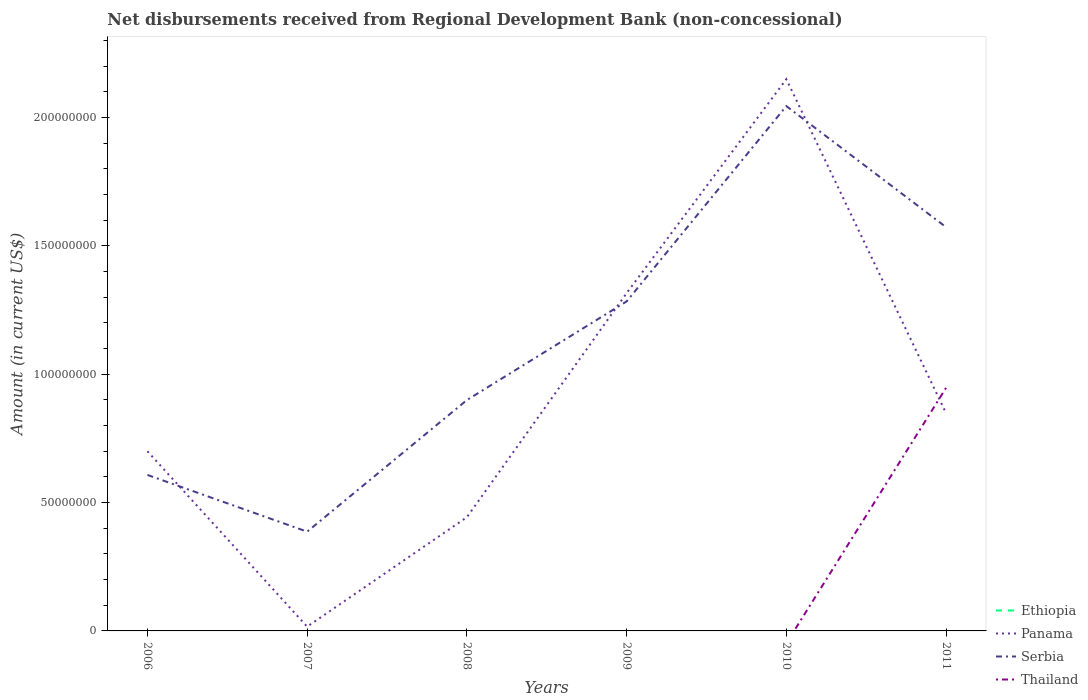How many different coloured lines are there?
Offer a very short reply. 3. Does the line corresponding to Ethiopia intersect with the line corresponding to Thailand?
Provide a succinct answer. Yes. Is the number of lines equal to the number of legend labels?
Give a very brief answer. No. What is the total amount of disbursements received from Regional Development Bank in Serbia in the graph?
Provide a short and direct response. -1.66e+08. What is the difference between the highest and the second highest amount of disbursements received from Regional Development Bank in Thailand?
Offer a terse response. 9.47e+07. What is the difference between the highest and the lowest amount of disbursements received from Regional Development Bank in Panama?
Provide a succinct answer. 2. Is the amount of disbursements received from Regional Development Bank in Panama strictly greater than the amount of disbursements received from Regional Development Bank in Thailand over the years?
Make the answer very short. No. Are the values on the major ticks of Y-axis written in scientific E-notation?
Your answer should be very brief. No. Does the graph contain any zero values?
Keep it short and to the point. Yes. How many legend labels are there?
Your answer should be compact. 4. What is the title of the graph?
Give a very brief answer. Net disbursements received from Regional Development Bank (non-concessional). Does "Europe(all income levels)" appear as one of the legend labels in the graph?
Keep it short and to the point. No. What is the Amount (in current US$) in Panama in 2006?
Ensure brevity in your answer.  7.00e+07. What is the Amount (in current US$) of Serbia in 2006?
Provide a short and direct response. 6.08e+07. What is the Amount (in current US$) in Panama in 2007?
Your response must be concise. 1.66e+06. What is the Amount (in current US$) of Serbia in 2007?
Your answer should be very brief. 3.87e+07. What is the Amount (in current US$) in Panama in 2008?
Offer a terse response. 4.43e+07. What is the Amount (in current US$) in Serbia in 2008?
Give a very brief answer. 8.99e+07. What is the Amount (in current US$) of Thailand in 2008?
Offer a very short reply. 0. What is the Amount (in current US$) in Ethiopia in 2009?
Make the answer very short. 0. What is the Amount (in current US$) in Panama in 2009?
Provide a short and direct response. 1.32e+08. What is the Amount (in current US$) of Serbia in 2009?
Your answer should be compact. 1.28e+08. What is the Amount (in current US$) in Thailand in 2009?
Provide a succinct answer. 0. What is the Amount (in current US$) of Panama in 2010?
Offer a very short reply. 2.15e+08. What is the Amount (in current US$) in Serbia in 2010?
Give a very brief answer. 2.04e+08. What is the Amount (in current US$) of Ethiopia in 2011?
Offer a very short reply. 0. What is the Amount (in current US$) of Panama in 2011?
Keep it short and to the point. 8.48e+07. What is the Amount (in current US$) in Serbia in 2011?
Your answer should be very brief. 1.57e+08. What is the Amount (in current US$) in Thailand in 2011?
Give a very brief answer. 9.47e+07. Across all years, what is the maximum Amount (in current US$) in Panama?
Your answer should be compact. 2.15e+08. Across all years, what is the maximum Amount (in current US$) in Serbia?
Your answer should be very brief. 2.04e+08. Across all years, what is the maximum Amount (in current US$) of Thailand?
Provide a short and direct response. 9.47e+07. Across all years, what is the minimum Amount (in current US$) in Panama?
Make the answer very short. 1.66e+06. Across all years, what is the minimum Amount (in current US$) in Serbia?
Your answer should be very brief. 3.87e+07. Across all years, what is the minimum Amount (in current US$) of Thailand?
Ensure brevity in your answer.  0. What is the total Amount (in current US$) of Panama in the graph?
Provide a short and direct response. 5.47e+08. What is the total Amount (in current US$) of Serbia in the graph?
Make the answer very short. 6.79e+08. What is the total Amount (in current US$) of Thailand in the graph?
Your answer should be very brief. 9.47e+07. What is the difference between the Amount (in current US$) of Panama in 2006 and that in 2007?
Your answer should be very brief. 6.83e+07. What is the difference between the Amount (in current US$) in Serbia in 2006 and that in 2007?
Provide a succinct answer. 2.21e+07. What is the difference between the Amount (in current US$) of Panama in 2006 and that in 2008?
Offer a very short reply. 2.57e+07. What is the difference between the Amount (in current US$) in Serbia in 2006 and that in 2008?
Offer a terse response. -2.92e+07. What is the difference between the Amount (in current US$) in Panama in 2006 and that in 2009?
Provide a short and direct response. -6.16e+07. What is the difference between the Amount (in current US$) of Serbia in 2006 and that in 2009?
Provide a succinct answer. -6.76e+07. What is the difference between the Amount (in current US$) of Panama in 2006 and that in 2010?
Offer a very short reply. -1.45e+08. What is the difference between the Amount (in current US$) of Serbia in 2006 and that in 2010?
Your response must be concise. -1.44e+08. What is the difference between the Amount (in current US$) in Panama in 2006 and that in 2011?
Offer a very short reply. -1.48e+07. What is the difference between the Amount (in current US$) of Serbia in 2006 and that in 2011?
Make the answer very short. -9.65e+07. What is the difference between the Amount (in current US$) in Panama in 2007 and that in 2008?
Your response must be concise. -4.26e+07. What is the difference between the Amount (in current US$) of Serbia in 2007 and that in 2008?
Your response must be concise. -5.13e+07. What is the difference between the Amount (in current US$) in Panama in 2007 and that in 2009?
Your answer should be compact. -1.30e+08. What is the difference between the Amount (in current US$) in Serbia in 2007 and that in 2009?
Ensure brevity in your answer.  -8.97e+07. What is the difference between the Amount (in current US$) in Panama in 2007 and that in 2010?
Provide a short and direct response. -2.13e+08. What is the difference between the Amount (in current US$) in Serbia in 2007 and that in 2010?
Offer a terse response. -1.66e+08. What is the difference between the Amount (in current US$) of Panama in 2007 and that in 2011?
Your answer should be very brief. -8.32e+07. What is the difference between the Amount (in current US$) in Serbia in 2007 and that in 2011?
Your response must be concise. -1.19e+08. What is the difference between the Amount (in current US$) in Panama in 2008 and that in 2009?
Offer a terse response. -8.73e+07. What is the difference between the Amount (in current US$) in Serbia in 2008 and that in 2009?
Offer a very short reply. -3.84e+07. What is the difference between the Amount (in current US$) in Panama in 2008 and that in 2010?
Offer a terse response. -1.71e+08. What is the difference between the Amount (in current US$) in Serbia in 2008 and that in 2010?
Your answer should be compact. -1.15e+08. What is the difference between the Amount (in current US$) of Panama in 2008 and that in 2011?
Ensure brevity in your answer.  -4.05e+07. What is the difference between the Amount (in current US$) in Serbia in 2008 and that in 2011?
Give a very brief answer. -6.74e+07. What is the difference between the Amount (in current US$) in Panama in 2009 and that in 2010?
Offer a terse response. -8.33e+07. What is the difference between the Amount (in current US$) in Serbia in 2009 and that in 2010?
Your answer should be compact. -7.61e+07. What is the difference between the Amount (in current US$) in Panama in 2009 and that in 2011?
Provide a succinct answer. 4.67e+07. What is the difference between the Amount (in current US$) in Serbia in 2009 and that in 2011?
Offer a terse response. -2.89e+07. What is the difference between the Amount (in current US$) in Panama in 2010 and that in 2011?
Offer a very short reply. 1.30e+08. What is the difference between the Amount (in current US$) in Serbia in 2010 and that in 2011?
Offer a terse response. 4.72e+07. What is the difference between the Amount (in current US$) of Panama in 2006 and the Amount (in current US$) of Serbia in 2007?
Ensure brevity in your answer.  3.13e+07. What is the difference between the Amount (in current US$) of Panama in 2006 and the Amount (in current US$) of Serbia in 2008?
Provide a succinct answer. -1.99e+07. What is the difference between the Amount (in current US$) of Panama in 2006 and the Amount (in current US$) of Serbia in 2009?
Ensure brevity in your answer.  -5.84e+07. What is the difference between the Amount (in current US$) of Panama in 2006 and the Amount (in current US$) of Serbia in 2010?
Provide a short and direct response. -1.34e+08. What is the difference between the Amount (in current US$) of Panama in 2006 and the Amount (in current US$) of Serbia in 2011?
Give a very brief answer. -8.73e+07. What is the difference between the Amount (in current US$) of Panama in 2006 and the Amount (in current US$) of Thailand in 2011?
Your response must be concise. -2.47e+07. What is the difference between the Amount (in current US$) of Serbia in 2006 and the Amount (in current US$) of Thailand in 2011?
Your answer should be compact. -3.39e+07. What is the difference between the Amount (in current US$) in Panama in 2007 and the Amount (in current US$) in Serbia in 2008?
Ensure brevity in your answer.  -8.83e+07. What is the difference between the Amount (in current US$) of Panama in 2007 and the Amount (in current US$) of Serbia in 2009?
Keep it short and to the point. -1.27e+08. What is the difference between the Amount (in current US$) of Panama in 2007 and the Amount (in current US$) of Serbia in 2010?
Keep it short and to the point. -2.03e+08. What is the difference between the Amount (in current US$) of Panama in 2007 and the Amount (in current US$) of Serbia in 2011?
Your answer should be very brief. -1.56e+08. What is the difference between the Amount (in current US$) in Panama in 2007 and the Amount (in current US$) in Thailand in 2011?
Provide a succinct answer. -9.30e+07. What is the difference between the Amount (in current US$) in Serbia in 2007 and the Amount (in current US$) in Thailand in 2011?
Ensure brevity in your answer.  -5.60e+07. What is the difference between the Amount (in current US$) in Panama in 2008 and the Amount (in current US$) in Serbia in 2009?
Ensure brevity in your answer.  -8.41e+07. What is the difference between the Amount (in current US$) in Panama in 2008 and the Amount (in current US$) in Serbia in 2010?
Offer a terse response. -1.60e+08. What is the difference between the Amount (in current US$) of Panama in 2008 and the Amount (in current US$) of Serbia in 2011?
Ensure brevity in your answer.  -1.13e+08. What is the difference between the Amount (in current US$) of Panama in 2008 and the Amount (in current US$) of Thailand in 2011?
Provide a succinct answer. -5.04e+07. What is the difference between the Amount (in current US$) of Serbia in 2008 and the Amount (in current US$) of Thailand in 2011?
Give a very brief answer. -4.76e+06. What is the difference between the Amount (in current US$) in Panama in 2009 and the Amount (in current US$) in Serbia in 2010?
Offer a very short reply. -7.29e+07. What is the difference between the Amount (in current US$) in Panama in 2009 and the Amount (in current US$) in Serbia in 2011?
Offer a very short reply. -2.57e+07. What is the difference between the Amount (in current US$) in Panama in 2009 and the Amount (in current US$) in Thailand in 2011?
Provide a succinct answer. 3.69e+07. What is the difference between the Amount (in current US$) in Serbia in 2009 and the Amount (in current US$) in Thailand in 2011?
Make the answer very short. 3.37e+07. What is the difference between the Amount (in current US$) of Panama in 2010 and the Amount (in current US$) of Serbia in 2011?
Your answer should be compact. 5.76e+07. What is the difference between the Amount (in current US$) of Panama in 2010 and the Amount (in current US$) of Thailand in 2011?
Ensure brevity in your answer.  1.20e+08. What is the difference between the Amount (in current US$) in Serbia in 2010 and the Amount (in current US$) in Thailand in 2011?
Your response must be concise. 1.10e+08. What is the average Amount (in current US$) of Ethiopia per year?
Provide a succinct answer. 0. What is the average Amount (in current US$) in Panama per year?
Provide a succinct answer. 9.12e+07. What is the average Amount (in current US$) in Serbia per year?
Ensure brevity in your answer.  1.13e+08. What is the average Amount (in current US$) of Thailand per year?
Provide a succinct answer. 1.58e+07. In the year 2006, what is the difference between the Amount (in current US$) of Panama and Amount (in current US$) of Serbia?
Keep it short and to the point. 9.23e+06. In the year 2007, what is the difference between the Amount (in current US$) in Panama and Amount (in current US$) in Serbia?
Give a very brief answer. -3.70e+07. In the year 2008, what is the difference between the Amount (in current US$) in Panama and Amount (in current US$) in Serbia?
Provide a short and direct response. -4.56e+07. In the year 2009, what is the difference between the Amount (in current US$) in Panama and Amount (in current US$) in Serbia?
Offer a very short reply. 3.23e+06. In the year 2010, what is the difference between the Amount (in current US$) in Panama and Amount (in current US$) in Serbia?
Make the answer very short. 1.05e+07. In the year 2011, what is the difference between the Amount (in current US$) in Panama and Amount (in current US$) in Serbia?
Make the answer very short. -7.25e+07. In the year 2011, what is the difference between the Amount (in current US$) in Panama and Amount (in current US$) in Thailand?
Ensure brevity in your answer.  -9.86e+06. In the year 2011, what is the difference between the Amount (in current US$) in Serbia and Amount (in current US$) in Thailand?
Your response must be concise. 6.26e+07. What is the ratio of the Amount (in current US$) in Panama in 2006 to that in 2007?
Keep it short and to the point. 42.29. What is the ratio of the Amount (in current US$) of Serbia in 2006 to that in 2007?
Keep it short and to the point. 1.57. What is the ratio of the Amount (in current US$) in Panama in 2006 to that in 2008?
Provide a succinct answer. 1.58. What is the ratio of the Amount (in current US$) in Serbia in 2006 to that in 2008?
Provide a succinct answer. 0.68. What is the ratio of the Amount (in current US$) in Panama in 2006 to that in 2009?
Your response must be concise. 0.53. What is the ratio of the Amount (in current US$) in Serbia in 2006 to that in 2009?
Offer a terse response. 0.47. What is the ratio of the Amount (in current US$) in Panama in 2006 to that in 2010?
Your answer should be very brief. 0.33. What is the ratio of the Amount (in current US$) of Serbia in 2006 to that in 2010?
Keep it short and to the point. 0.3. What is the ratio of the Amount (in current US$) in Panama in 2006 to that in 2011?
Your answer should be very brief. 0.83. What is the ratio of the Amount (in current US$) of Serbia in 2006 to that in 2011?
Make the answer very short. 0.39. What is the ratio of the Amount (in current US$) of Panama in 2007 to that in 2008?
Offer a terse response. 0.04. What is the ratio of the Amount (in current US$) in Serbia in 2007 to that in 2008?
Provide a short and direct response. 0.43. What is the ratio of the Amount (in current US$) of Panama in 2007 to that in 2009?
Offer a very short reply. 0.01. What is the ratio of the Amount (in current US$) of Serbia in 2007 to that in 2009?
Your answer should be very brief. 0.3. What is the ratio of the Amount (in current US$) in Panama in 2007 to that in 2010?
Keep it short and to the point. 0.01. What is the ratio of the Amount (in current US$) in Serbia in 2007 to that in 2010?
Offer a terse response. 0.19. What is the ratio of the Amount (in current US$) of Panama in 2007 to that in 2011?
Make the answer very short. 0.02. What is the ratio of the Amount (in current US$) of Serbia in 2007 to that in 2011?
Offer a terse response. 0.25. What is the ratio of the Amount (in current US$) of Panama in 2008 to that in 2009?
Provide a succinct answer. 0.34. What is the ratio of the Amount (in current US$) in Serbia in 2008 to that in 2009?
Make the answer very short. 0.7. What is the ratio of the Amount (in current US$) in Panama in 2008 to that in 2010?
Keep it short and to the point. 0.21. What is the ratio of the Amount (in current US$) of Serbia in 2008 to that in 2010?
Your answer should be compact. 0.44. What is the ratio of the Amount (in current US$) of Panama in 2008 to that in 2011?
Your answer should be compact. 0.52. What is the ratio of the Amount (in current US$) of Serbia in 2008 to that in 2011?
Give a very brief answer. 0.57. What is the ratio of the Amount (in current US$) of Panama in 2009 to that in 2010?
Your answer should be very brief. 0.61. What is the ratio of the Amount (in current US$) of Serbia in 2009 to that in 2010?
Provide a succinct answer. 0.63. What is the ratio of the Amount (in current US$) in Panama in 2009 to that in 2011?
Ensure brevity in your answer.  1.55. What is the ratio of the Amount (in current US$) in Serbia in 2009 to that in 2011?
Make the answer very short. 0.82. What is the ratio of the Amount (in current US$) in Panama in 2010 to that in 2011?
Provide a succinct answer. 2.53. What is the ratio of the Amount (in current US$) of Serbia in 2010 to that in 2011?
Offer a terse response. 1.3. What is the difference between the highest and the second highest Amount (in current US$) in Panama?
Ensure brevity in your answer.  8.33e+07. What is the difference between the highest and the second highest Amount (in current US$) of Serbia?
Offer a terse response. 4.72e+07. What is the difference between the highest and the lowest Amount (in current US$) in Panama?
Ensure brevity in your answer.  2.13e+08. What is the difference between the highest and the lowest Amount (in current US$) of Serbia?
Your answer should be compact. 1.66e+08. What is the difference between the highest and the lowest Amount (in current US$) of Thailand?
Offer a very short reply. 9.47e+07. 